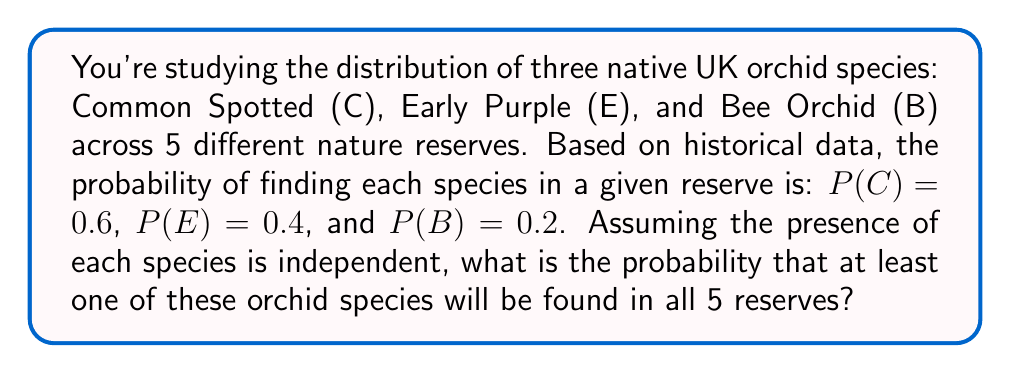Teach me how to tackle this problem. Let's approach this step-by-step:

1) First, we need to calculate the probability of finding at least one of these orchid species in a single reserve. This is easier to calculate by finding the probability of not finding any of the species and then subtracting from 1.

2) The probability of not finding a specific species is:
   $P(\text{not C}) = 1 - 0.6 = 0.4$
   $P(\text{not E}) = 1 - 0.4 = 0.6$
   $P(\text{not B}) = 1 - 0.2 = 0.8$

3) The probability of not finding any of the species in a single reserve is:
   $P(\text{none}) = 0.4 \times 0.6 \times 0.8 = 0.192$

4) Therefore, the probability of finding at least one species in a single reserve is:
   $P(\text{at least one}) = 1 - 0.192 = 0.808$

5) Now, for this to occur in all 5 reserves, we need to multiply this probability by itself 5 times:
   $P(\text{at least one in all 5}) = 0.808^5$

6) Calculating this:
   $0.808^5 \approx 0.3430$

Therefore, the probability of finding at least one of these orchid species in all 5 reserves is approximately 0.3430 or 34.30%.
Answer: 0.3430 